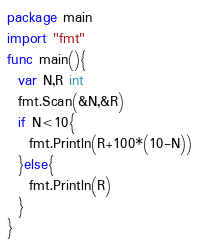Convert code to text. <code><loc_0><loc_0><loc_500><loc_500><_Go_>package main
import "fmt"
func main(){
  var N,R int
  fmt.Scan(&N,&R)
  if N<10{
    fmt.Println(R+100*(10-N))
  }else{
    fmt.Println(R)
  }
}</code> 